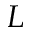Convert formula to latex. <formula><loc_0><loc_0><loc_500><loc_500>L</formula> 